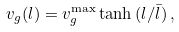Convert formula to latex. <formula><loc_0><loc_0><loc_500><loc_500>v _ { g } ( l ) = v _ { g } ^ { \max } \tanh { ( l / \bar { l } ) } \, ,</formula> 